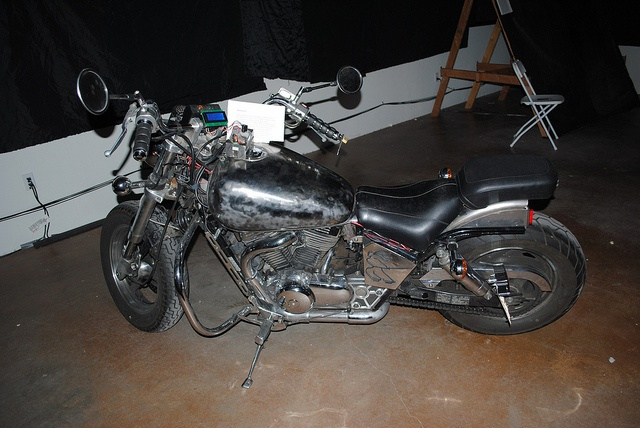Describe the objects in this image and their specific colors. I can see motorcycle in black, gray, darkgray, and white tones and chair in black, darkgray, gray, and maroon tones in this image. 